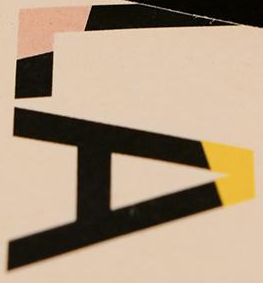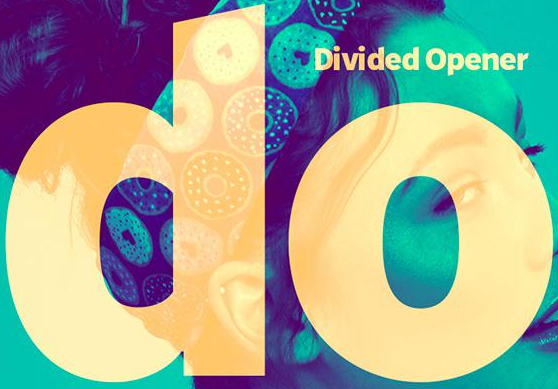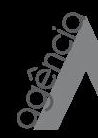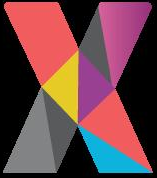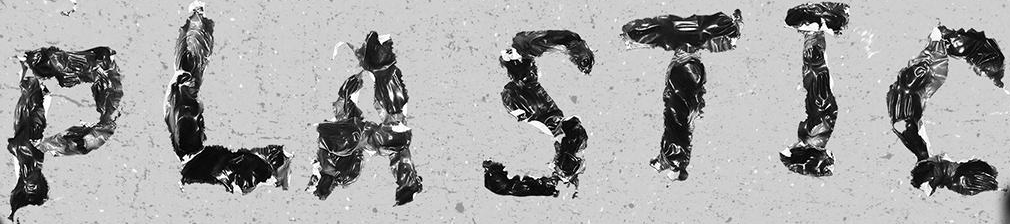What text is displayed in these images sequentially, separated by a semicolon? LA; do; agência; X; PLASTIC 